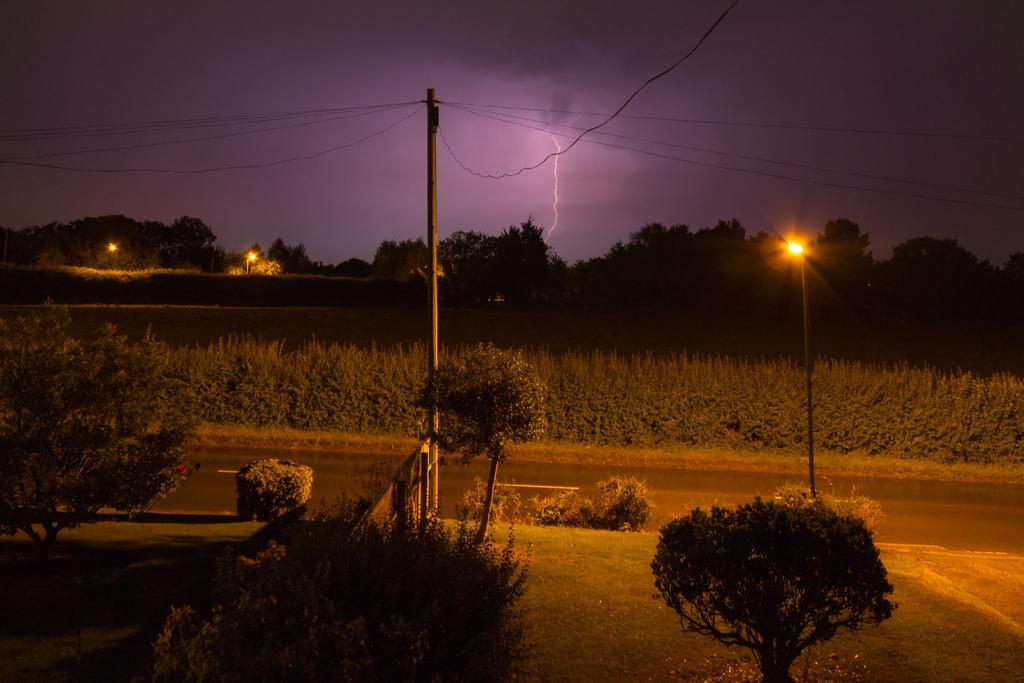Describe this image in one or two sentences. In this image we can see some plants, road, there are some street lights, current poles, wires and in the background there are some trees and lightning sky. 